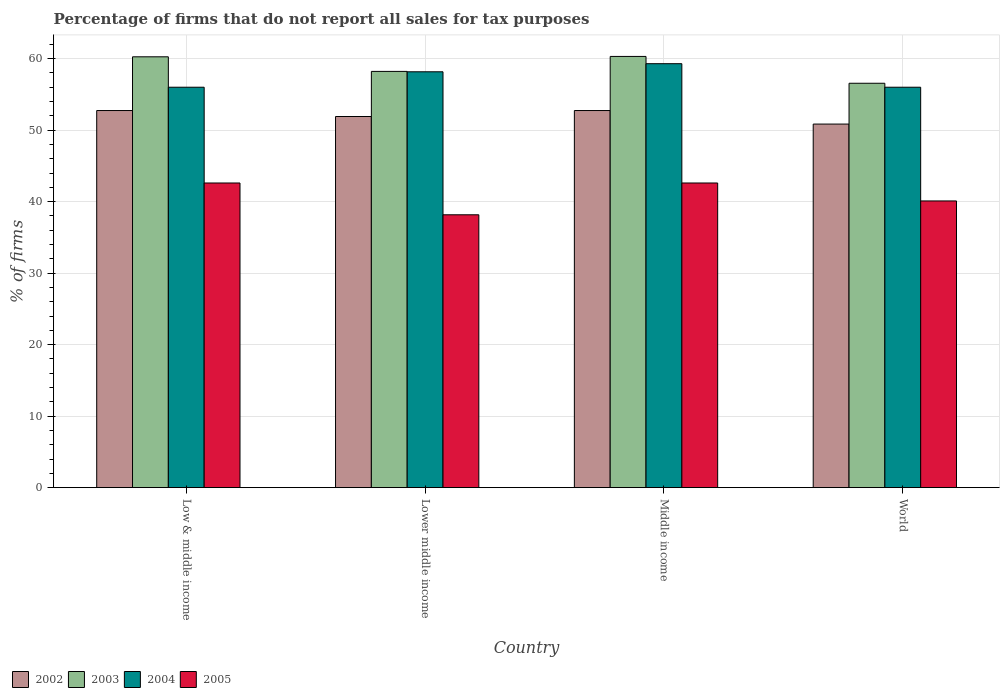How many different coloured bars are there?
Provide a short and direct response. 4. Are the number of bars on each tick of the X-axis equal?
Ensure brevity in your answer.  Yes. How many bars are there on the 1st tick from the left?
Make the answer very short. 4. How many bars are there on the 2nd tick from the right?
Offer a very short reply. 4. What is the percentage of firms that do not report all sales for tax purposes in 2002 in Low & middle income?
Your response must be concise. 52.75. Across all countries, what is the maximum percentage of firms that do not report all sales for tax purposes in 2003?
Offer a very short reply. 60.31. Across all countries, what is the minimum percentage of firms that do not report all sales for tax purposes in 2004?
Provide a short and direct response. 56.01. What is the total percentage of firms that do not report all sales for tax purposes in 2004 in the graph?
Give a very brief answer. 229.47. What is the difference between the percentage of firms that do not report all sales for tax purposes in 2003 in Lower middle income and that in Middle income?
Offer a very short reply. -2.09. What is the difference between the percentage of firms that do not report all sales for tax purposes in 2005 in Low & middle income and the percentage of firms that do not report all sales for tax purposes in 2004 in Middle income?
Provide a short and direct response. -16.69. What is the average percentage of firms that do not report all sales for tax purposes in 2005 per country?
Offer a terse response. 40.87. What is the difference between the percentage of firms that do not report all sales for tax purposes of/in 2003 and percentage of firms that do not report all sales for tax purposes of/in 2002 in Low & middle income?
Keep it short and to the point. 7.51. What is the ratio of the percentage of firms that do not report all sales for tax purposes in 2005 in Low & middle income to that in Lower middle income?
Your answer should be compact. 1.12. Is the percentage of firms that do not report all sales for tax purposes in 2005 in Middle income less than that in World?
Your answer should be compact. No. What is the difference between the highest and the second highest percentage of firms that do not report all sales for tax purposes in 2003?
Ensure brevity in your answer.  -2.09. What is the difference between the highest and the lowest percentage of firms that do not report all sales for tax purposes in 2002?
Your answer should be compact. 1.89. In how many countries, is the percentage of firms that do not report all sales for tax purposes in 2002 greater than the average percentage of firms that do not report all sales for tax purposes in 2002 taken over all countries?
Your response must be concise. 2. Is the sum of the percentage of firms that do not report all sales for tax purposes in 2005 in Low & middle income and Middle income greater than the maximum percentage of firms that do not report all sales for tax purposes in 2003 across all countries?
Make the answer very short. Yes. Is it the case that in every country, the sum of the percentage of firms that do not report all sales for tax purposes in 2004 and percentage of firms that do not report all sales for tax purposes in 2003 is greater than the sum of percentage of firms that do not report all sales for tax purposes in 2005 and percentage of firms that do not report all sales for tax purposes in 2002?
Ensure brevity in your answer.  Yes. What does the 4th bar from the left in Middle income represents?
Give a very brief answer. 2005. What does the 4th bar from the right in World represents?
Keep it short and to the point. 2002. Is it the case that in every country, the sum of the percentage of firms that do not report all sales for tax purposes in 2005 and percentage of firms that do not report all sales for tax purposes in 2002 is greater than the percentage of firms that do not report all sales for tax purposes in 2003?
Give a very brief answer. Yes. How many countries are there in the graph?
Make the answer very short. 4. Are the values on the major ticks of Y-axis written in scientific E-notation?
Your response must be concise. No. Does the graph contain any zero values?
Your response must be concise. No. Does the graph contain grids?
Offer a very short reply. Yes. How many legend labels are there?
Your answer should be compact. 4. How are the legend labels stacked?
Your answer should be very brief. Horizontal. What is the title of the graph?
Ensure brevity in your answer.  Percentage of firms that do not report all sales for tax purposes. What is the label or title of the Y-axis?
Offer a terse response. % of firms. What is the % of firms of 2002 in Low & middle income?
Your answer should be very brief. 52.75. What is the % of firms of 2003 in Low & middle income?
Provide a short and direct response. 60.26. What is the % of firms in 2004 in Low & middle income?
Provide a succinct answer. 56.01. What is the % of firms in 2005 in Low & middle income?
Give a very brief answer. 42.61. What is the % of firms of 2002 in Lower middle income?
Give a very brief answer. 51.91. What is the % of firms in 2003 in Lower middle income?
Offer a terse response. 58.22. What is the % of firms of 2004 in Lower middle income?
Your response must be concise. 58.16. What is the % of firms in 2005 in Lower middle income?
Provide a short and direct response. 38.16. What is the % of firms of 2002 in Middle income?
Your answer should be compact. 52.75. What is the % of firms of 2003 in Middle income?
Your response must be concise. 60.31. What is the % of firms in 2004 in Middle income?
Keep it short and to the point. 59.3. What is the % of firms of 2005 in Middle income?
Provide a short and direct response. 42.61. What is the % of firms in 2002 in World?
Provide a succinct answer. 50.85. What is the % of firms of 2003 in World?
Ensure brevity in your answer.  56.56. What is the % of firms in 2004 in World?
Provide a succinct answer. 56.01. What is the % of firms in 2005 in World?
Ensure brevity in your answer.  40.1. Across all countries, what is the maximum % of firms of 2002?
Provide a short and direct response. 52.75. Across all countries, what is the maximum % of firms in 2003?
Offer a very short reply. 60.31. Across all countries, what is the maximum % of firms of 2004?
Offer a terse response. 59.3. Across all countries, what is the maximum % of firms of 2005?
Offer a very short reply. 42.61. Across all countries, what is the minimum % of firms of 2002?
Your answer should be compact. 50.85. Across all countries, what is the minimum % of firms in 2003?
Make the answer very short. 56.56. Across all countries, what is the minimum % of firms in 2004?
Provide a succinct answer. 56.01. Across all countries, what is the minimum % of firms in 2005?
Keep it short and to the point. 38.16. What is the total % of firms of 2002 in the graph?
Make the answer very short. 208.25. What is the total % of firms in 2003 in the graph?
Offer a very short reply. 235.35. What is the total % of firms in 2004 in the graph?
Keep it short and to the point. 229.47. What is the total % of firms in 2005 in the graph?
Provide a succinct answer. 163.48. What is the difference between the % of firms of 2002 in Low & middle income and that in Lower middle income?
Offer a terse response. 0.84. What is the difference between the % of firms in 2003 in Low & middle income and that in Lower middle income?
Make the answer very short. 2.04. What is the difference between the % of firms in 2004 in Low & middle income and that in Lower middle income?
Keep it short and to the point. -2.16. What is the difference between the % of firms of 2005 in Low & middle income and that in Lower middle income?
Provide a short and direct response. 4.45. What is the difference between the % of firms in 2003 in Low & middle income and that in Middle income?
Provide a succinct answer. -0.05. What is the difference between the % of firms of 2004 in Low & middle income and that in Middle income?
Your response must be concise. -3.29. What is the difference between the % of firms of 2002 in Low & middle income and that in World?
Your answer should be compact. 1.89. What is the difference between the % of firms in 2003 in Low & middle income and that in World?
Your answer should be compact. 3.7. What is the difference between the % of firms of 2005 in Low & middle income and that in World?
Provide a short and direct response. 2.51. What is the difference between the % of firms of 2002 in Lower middle income and that in Middle income?
Make the answer very short. -0.84. What is the difference between the % of firms in 2003 in Lower middle income and that in Middle income?
Ensure brevity in your answer.  -2.09. What is the difference between the % of firms of 2004 in Lower middle income and that in Middle income?
Your answer should be compact. -1.13. What is the difference between the % of firms of 2005 in Lower middle income and that in Middle income?
Your answer should be compact. -4.45. What is the difference between the % of firms in 2002 in Lower middle income and that in World?
Your answer should be very brief. 1.06. What is the difference between the % of firms of 2003 in Lower middle income and that in World?
Offer a very short reply. 1.66. What is the difference between the % of firms in 2004 in Lower middle income and that in World?
Provide a short and direct response. 2.16. What is the difference between the % of firms of 2005 in Lower middle income and that in World?
Your answer should be very brief. -1.94. What is the difference between the % of firms in 2002 in Middle income and that in World?
Your answer should be very brief. 1.89. What is the difference between the % of firms of 2003 in Middle income and that in World?
Your response must be concise. 3.75. What is the difference between the % of firms in 2004 in Middle income and that in World?
Provide a succinct answer. 3.29. What is the difference between the % of firms in 2005 in Middle income and that in World?
Your answer should be compact. 2.51. What is the difference between the % of firms in 2002 in Low & middle income and the % of firms in 2003 in Lower middle income?
Keep it short and to the point. -5.47. What is the difference between the % of firms in 2002 in Low & middle income and the % of firms in 2004 in Lower middle income?
Provide a short and direct response. -5.42. What is the difference between the % of firms of 2002 in Low & middle income and the % of firms of 2005 in Lower middle income?
Your response must be concise. 14.58. What is the difference between the % of firms of 2003 in Low & middle income and the % of firms of 2004 in Lower middle income?
Offer a very short reply. 2.1. What is the difference between the % of firms in 2003 in Low & middle income and the % of firms in 2005 in Lower middle income?
Offer a very short reply. 22.1. What is the difference between the % of firms of 2004 in Low & middle income and the % of firms of 2005 in Lower middle income?
Ensure brevity in your answer.  17.84. What is the difference between the % of firms in 2002 in Low & middle income and the % of firms in 2003 in Middle income?
Your answer should be very brief. -7.57. What is the difference between the % of firms in 2002 in Low & middle income and the % of firms in 2004 in Middle income?
Provide a short and direct response. -6.55. What is the difference between the % of firms in 2002 in Low & middle income and the % of firms in 2005 in Middle income?
Make the answer very short. 10.13. What is the difference between the % of firms of 2003 in Low & middle income and the % of firms of 2004 in Middle income?
Ensure brevity in your answer.  0.96. What is the difference between the % of firms in 2003 in Low & middle income and the % of firms in 2005 in Middle income?
Offer a very short reply. 17.65. What is the difference between the % of firms of 2004 in Low & middle income and the % of firms of 2005 in Middle income?
Make the answer very short. 13.39. What is the difference between the % of firms in 2002 in Low & middle income and the % of firms in 2003 in World?
Provide a succinct answer. -3.81. What is the difference between the % of firms in 2002 in Low & middle income and the % of firms in 2004 in World?
Provide a short and direct response. -3.26. What is the difference between the % of firms of 2002 in Low & middle income and the % of firms of 2005 in World?
Provide a succinct answer. 12.65. What is the difference between the % of firms in 2003 in Low & middle income and the % of firms in 2004 in World?
Offer a terse response. 4.25. What is the difference between the % of firms of 2003 in Low & middle income and the % of firms of 2005 in World?
Give a very brief answer. 20.16. What is the difference between the % of firms in 2004 in Low & middle income and the % of firms in 2005 in World?
Provide a succinct answer. 15.91. What is the difference between the % of firms in 2002 in Lower middle income and the % of firms in 2003 in Middle income?
Offer a very short reply. -8.4. What is the difference between the % of firms in 2002 in Lower middle income and the % of firms in 2004 in Middle income?
Offer a terse response. -7.39. What is the difference between the % of firms in 2002 in Lower middle income and the % of firms in 2005 in Middle income?
Your response must be concise. 9.3. What is the difference between the % of firms of 2003 in Lower middle income and the % of firms of 2004 in Middle income?
Provide a short and direct response. -1.08. What is the difference between the % of firms in 2003 in Lower middle income and the % of firms in 2005 in Middle income?
Keep it short and to the point. 15.61. What is the difference between the % of firms in 2004 in Lower middle income and the % of firms in 2005 in Middle income?
Ensure brevity in your answer.  15.55. What is the difference between the % of firms of 2002 in Lower middle income and the % of firms of 2003 in World?
Keep it short and to the point. -4.65. What is the difference between the % of firms in 2002 in Lower middle income and the % of firms in 2004 in World?
Your answer should be very brief. -4.1. What is the difference between the % of firms in 2002 in Lower middle income and the % of firms in 2005 in World?
Give a very brief answer. 11.81. What is the difference between the % of firms in 2003 in Lower middle income and the % of firms in 2004 in World?
Your response must be concise. 2.21. What is the difference between the % of firms of 2003 in Lower middle income and the % of firms of 2005 in World?
Keep it short and to the point. 18.12. What is the difference between the % of firms of 2004 in Lower middle income and the % of firms of 2005 in World?
Give a very brief answer. 18.07. What is the difference between the % of firms of 2002 in Middle income and the % of firms of 2003 in World?
Provide a short and direct response. -3.81. What is the difference between the % of firms of 2002 in Middle income and the % of firms of 2004 in World?
Offer a terse response. -3.26. What is the difference between the % of firms of 2002 in Middle income and the % of firms of 2005 in World?
Your answer should be very brief. 12.65. What is the difference between the % of firms in 2003 in Middle income and the % of firms in 2004 in World?
Keep it short and to the point. 4.31. What is the difference between the % of firms of 2003 in Middle income and the % of firms of 2005 in World?
Offer a terse response. 20.21. What is the difference between the % of firms in 2004 in Middle income and the % of firms in 2005 in World?
Provide a short and direct response. 19.2. What is the average % of firms in 2002 per country?
Your answer should be very brief. 52.06. What is the average % of firms in 2003 per country?
Provide a short and direct response. 58.84. What is the average % of firms of 2004 per country?
Offer a very short reply. 57.37. What is the average % of firms of 2005 per country?
Ensure brevity in your answer.  40.87. What is the difference between the % of firms in 2002 and % of firms in 2003 in Low & middle income?
Offer a very short reply. -7.51. What is the difference between the % of firms of 2002 and % of firms of 2004 in Low & middle income?
Offer a very short reply. -3.26. What is the difference between the % of firms of 2002 and % of firms of 2005 in Low & middle income?
Give a very brief answer. 10.13. What is the difference between the % of firms of 2003 and % of firms of 2004 in Low & middle income?
Your answer should be very brief. 4.25. What is the difference between the % of firms of 2003 and % of firms of 2005 in Low & middle income?
Offer a very short reply. 17.65. What is the difference between the % of firms in 2004 and % of firms in 2005 in Low & middle income?
Ensure brevity in your answer.  13.39. What is the difference between the % of firms of 2002 and % of firms of 2003 in Lower middle income?
Offer a terse response. -6.31. What is the difference between the % of firms of 2002 and % of firms of 2004 in Lower middle income?
Provide a short and direct response. -6.26. What is the difference between the % of firms in 2002 and % of firms in 2005 in Lower middle income?
Provide a short and direct response. 13.75. What is the difference between the % of firms of 2003 and % of firms of 2004 in Lower middle income?
Provide a short and direct response. 0.05. What is the difference between the % of firms of 2003 and % of firms of 2005 in Lower middle income?
Provide a short and direct response. 20.06. What is the difference between the % of firms in 2004 and % of firms in 2005 in Lower middle income?
Provide a succinct answer. 20. What is the difference between the % of firms in 2002 and % of firms in 2003 in Middle income?
Ensure brevity in your answer.  -7.57. What is the difference between the % of firms in 2002 and % of firms in 2004 in Middle income?
Offer a very short reply. -6.55. What is the difference between the % of firms of 2002 and % of firms of 2005 in Middle income?
Provide a short and direct response. 10.13. What is the difference between the % of firms in 2003 and % of firms in 2004 in Middle income?
Keep it short and to the point. 1.02. What is the difference between the % of firms in 2003 and % of firms in 2005 in Middle income?
Ensure brevity in your answer.  17.7. What is the difference between the % of firms of 2004 and % of firms of 2005 in Middle income?
Your response must be concise. 16.69. What is the difference between the % of firms in 2002 and % of firms in 2003 in World?
Keep it short and to the point. -5.71. What is the difference between the % of firms in 2002 and % of firms in 2004 in World?
Provide a short and direct response. -5.15. What is the difference between the % of firms of 2002 and % of firms of 2005 in World?
Keep it short and to the point. 10.75. What is the difference between the % of firms in 2003 and % of firms in 2004 in World?
Your answer should be compact. 0.56. What is the difference between the % of firms of 2003 and % of firms of 2005 in World?
Give a very brief answer. 16.46. What is the difference between the % of firms of 2004 and % of firms of 2005 in World?
Offer a very short reply. 15.91. What is the ratio of the % of firms in 2002 in Low & middle income to that in Lower middle income?
Give a very brief answer. 1.02. What is the ratio of the % of firms of 2003 in Low & middle income to that in Lower middle income?
Give a very brief answer. 1.04. What is the ratio of the % of firms of 2004 in Low & middle income to that in Lower middle income?
Your response must be concise. 0.96. What is the ratio of the % of firms of 2005 in Low & middle income to that in Lower middle income?
Offer a very short reply. 1.12. What is the ratio of the % of firms in 2002 in Low & middle income to that in Middle income?
Give a very brief answer. 1. What is the ratio of the % of firms of 2003 in Low & middle income to that in Middle income?
Give a very brief answer. 1. What is the ratio of the % of firms of 2004 in Low & middle income to that in Middle income?
Your response must be concise. 0.94. What is the ratio of the % of firms of 2005 in Low & middle income to that in Middle income?
Your response must be concise. 1. What is the ratio of the % of firms of 2002 in Low & middle income to that in World?
Give a very brief answer. 1.04. What is the ratio of the % of firms of 2003 in Low & middle income to that in World?
Your answer should be very brief. 1.07. What is the ratio of the % of firms of 2004 in Low & middle income to that in World?
Make the answer very short. 1. What is the ratio of the % of firms of 2005 in Low & middle income to that in World?
Keep it short and to the point. 1.06. What is the ratio of the % of firms of 2002 in Lower middle income to that in Middle income?
Provide a succinct answer. 0.98. What is the ratio of the % of firms of 2003 in Lower middle income to that in Middle income?
Give a very brief answer. 0.97. What is the ratio of the % of firms of 2004 in Lower middle income to that in Middle income?
Provide a succinct answer. 0.98. What is the ratio of the % of firms of 2005 in Lower middle income to that in Middle income?
Provide a succinct answer. 0.9. What is the ratio of the % of firms in 2002 in Lower middle income to that in World?
Your response must be concise. 1.02. What is the ratio of the % of firms in 2003 in Lower middle income to that in World?
Your answer should be compact. 1.03. What is the ratio of the % of firms in 2004 in Lower middle income to that in World?
Provide a short and direct response. 1.04. What is the ratio of the % of firms of 2005 in Lower middle income to that in World?
Give a very brief answer. 0.95. What is the ratio of the % of firms in 2002 in Middle income to that in World?
Ensure brevity in your answer.  1.04. What is the ratio of the % of firms in 2003 in Middle income to that in World?
Keep it short and to the point. 1.07. What is the ratio of the % of firms in 2004 in Middle income to that in World?
Your response must be concise. 1.06. What is the ratio of the % of firms in 2005 in Middle income to that in World?
Offer a terse response. 1.06. What is the difference between the highest and the second highest % of firms of 2003?
Keep it short and to the point. 0.05. What is the difference between the highest and the second highest % of firms in 2004?
Your response must be concise. 1.13. What is the difference between the highest and the second highest % of firms of 2005?
Provide a short and direct response. 0. What is the difference between the highest and the lowest % of firms in 2002?
Your answer should be compact. 1.89. What is the difference between the highest and the lowest % of firms of 2003?
Offer a terse response. 3.75. What is the difference between the highest and the lowest % of firms in 2004?
Your response must be concise. 3.29. What is the difference between the highest and the lowest % of firms of 2005?
Offer a very short reply. 4.45. 